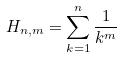Convert formula to latex. <formula><loc_0><loc_0><loc_500><loc_500>H _ { n , m } = \sum _ { k = 1 } ^ { n } \frac { 1 } { k ^ { m } }</formula> 